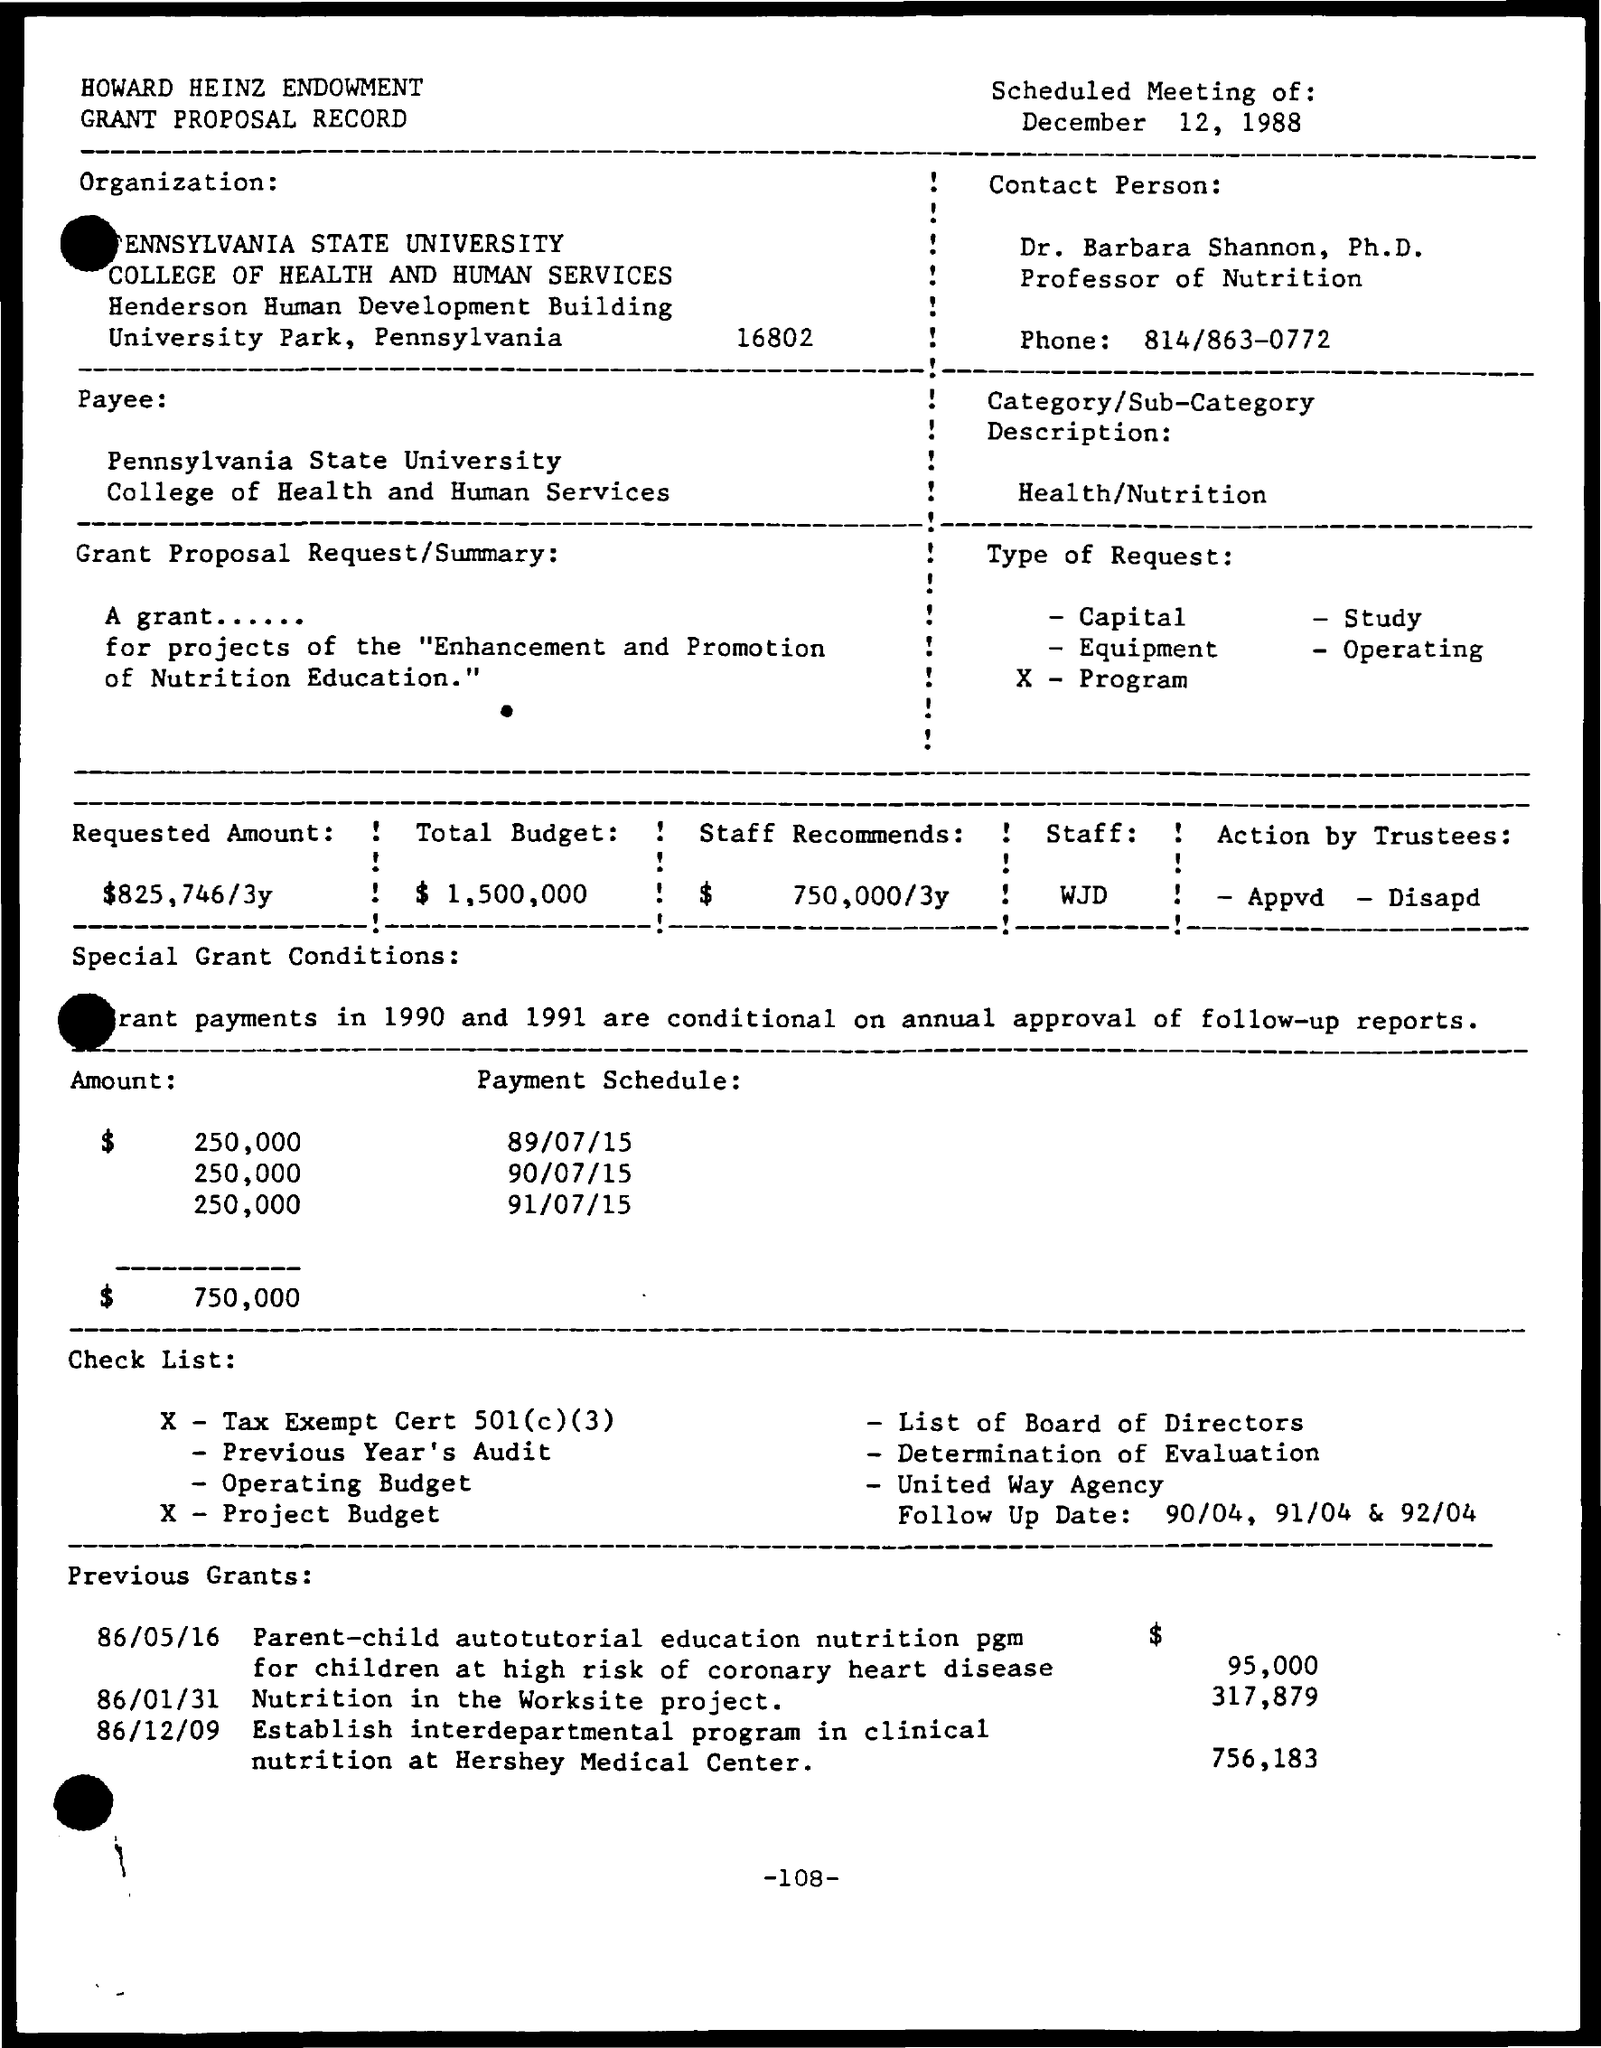Specify some key components in this picture. The Nutrition in the worksite project was previously awarded a grant of $317,879. The date scheduled for the meeting is December 12, 1988. The recommended amount by staff is $750,000 to be allocated over a period of 3 years. The requested amount is $825,746 spread out over a three-year period. The total budget is $1,500,000. 